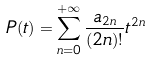Convert formula to latex. <formula><loc_0><loc_0><loc_500><loc_500>P ( t ) = \sum _ { n = 0 } ^ { + \infty } \frac { a _ { 2 n } } { ( 2 n ) ! } t ^ { 2 n }</formula> 